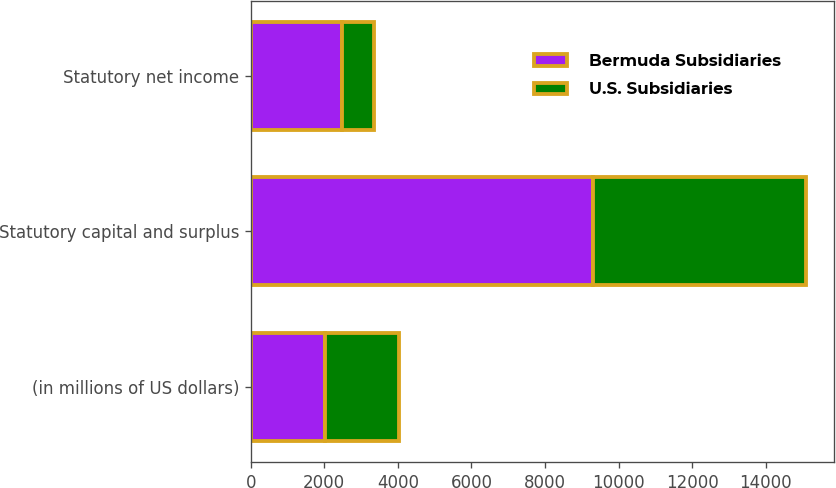<chart> <loc_0><loc_0><loc_500><loc_500><stacked_bar_chart><ecel><fcel>(in millions of US dollars)<fcel>Statutory capital and surplus<fcel>Statutory net income<nl><fcel>Bermuda Subsidiaries<fcel>2009<fcel>9299<fcel>2472<nl><fcel>U.S. Subsidiaries<fcel>2009<fcel>5801<fcel>870<nl></chart> 